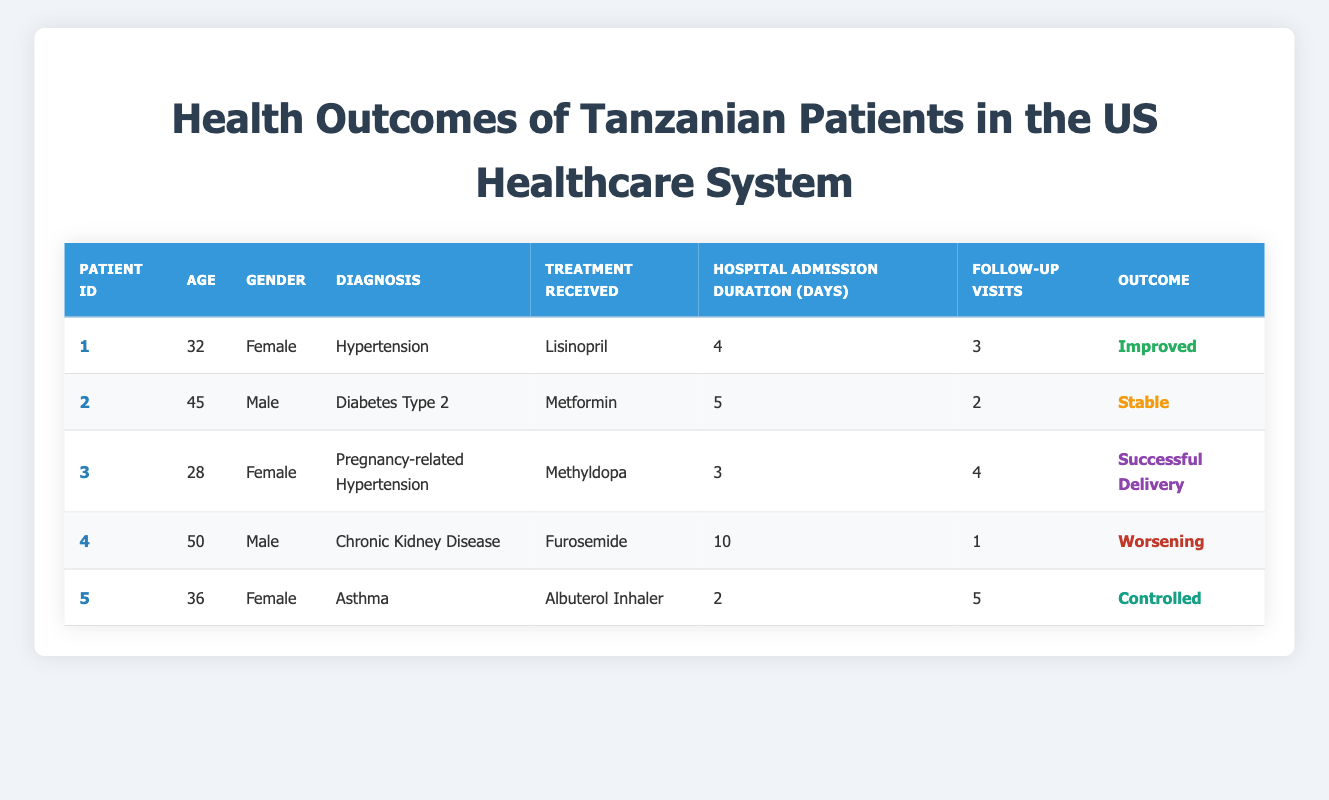What is the length of hospital admission for the patient with diagnosis of Diabetes Type 2? The entry for the patient with a diagnosis of Diabetes Type 2 is identified in the table as Patient ID 2. The hospital admission duration listed for this patient is 5 days.
Answer: 5 days How many follow-up visits did the female patient with asthma have? The patient with asthma is identified as Patient ID 5. In the table, it states that this patient had 5 follow-up visits.
Answer: 5 Which treatment was given to the patient diagnosed with Chronic Kidney Disease? The row for the patient identified as having Chronic Kidney Disease, Patient ID 4, shows that the treatment received was Furosemide.
Answer: Furosemide Is there any patient listed as having a successful outcome for their treatment? Looking at the outcomes in the table, Patient ID 3, who had Pregnancy-related Hypertension, shows an outcome of Successful Delivery. This indicates a successful outcome is present.
Answer: Yes What is the average age of the patients in this dataset? To find the average age, we add the ages of all patients: 32 + 45 + 28 + 50 + 36 = 191. Then, we divide by the number of patients (5): 191 / 5 = 38.2. Therefore, the average age is 38.2 years.
Answer: 38.2 How many patients received follow-up visits equal to or greater than 3? From the table, we observe the follow-up visits for each patient: Patient 1 (3), Patient 2 (2), Patient 3 (4), Patient 4 (1), Patient 5 (5). The patients with follow-up visits equal to or greater than 3 are Patient 1, Patient 3, and Patient 5. Therefore, there are 3 patients.
Answer: 3 Was any patient treated with Methyldopa? The table lists Patient ID 3 as having received Methyldopa for their treatment of Pregnancy-related Hypertension. Hence, the statement is true.
Answer: Yes What is the maximum length of hospital admission across all patients? By examining the hospital admission duration for each patient: 4 days, 5 days, 3 days, 10 days, and 2 days, we find that the maximum duration is 10 days for the patient with Chronic Kidney Disease.
Answer: 10 days How many total follow-up visits were conducted for all patients? To find the total follow-up visits, we add the follow-up visits from each patient: 3 + 2 + 4 + 1 + 5 = 15. The total number of follow-up visits conducted for all patients is therefore 15.
Answer: 15 